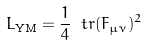Convert formula to latex. <formula><loc_0><loc_0><loc_500><loc_500>\L L _ { \text {YM} } = \frac { 1 } { 4 } \ t r ( F _ { \mu \nu } ) ^ { 2 }</formula> 